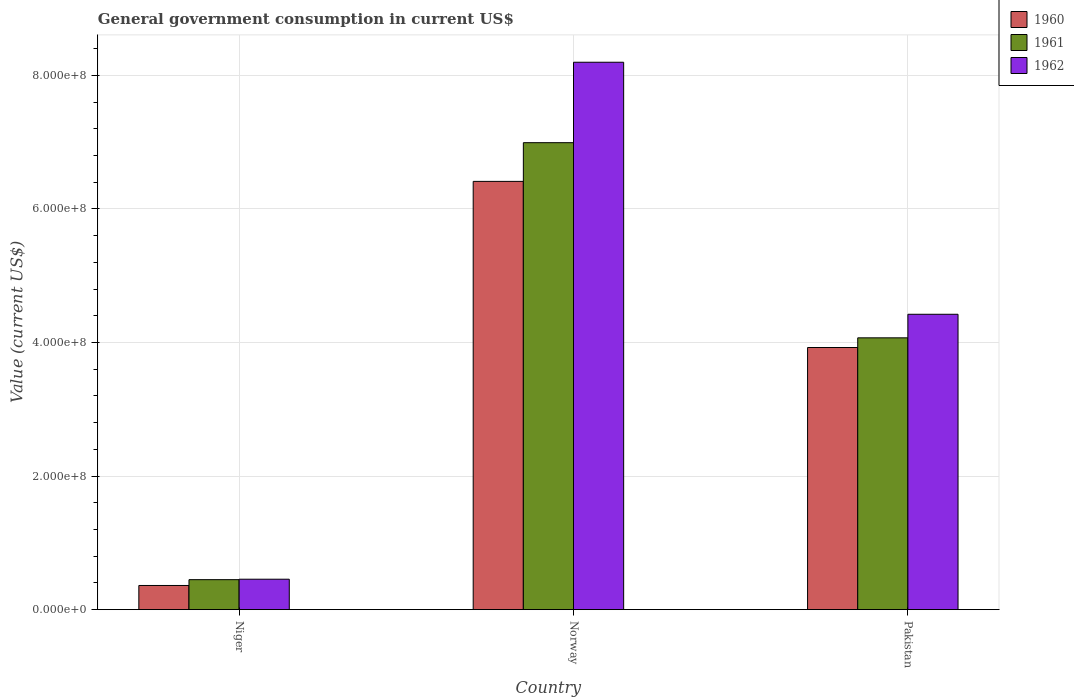How many different coloured bars are there?
Offer a terse response. 3. Are the number of bars per tick equal to the number of legend labels?
Provide a short and direct response. Yes. Are the number of bars on each tick of the X-axis equal?
Provide a short and direct response. Yes. How many bars are there on the 1st tick from the left?
Offer a very short reply. 3. In how many cases, is the number of bars for a given country not equal to the number of legend labels?
Make the answer very short. 0. What is the government conusmption in 1961 in Norway?
Offer a very short reply. 6.99e+08. Across all countries, what is the maximum government conusmption in 1961?
Offer a terse response. 6.99e+08. Across all countries, what is the minimum government conusmption in 1962?
Offer a very short reply. 4.55e+07. In which country was the government conusmption in 1962 minimum?
Make the answer very short. Niger. What is the total government conusmption in 1962 in the graph?
Provide a short and direct response. 1.31e+09. What is the difference between the government conusmption in 1960 in Niger and that in Norway?
Your answer should be compact. -6.05e+08. What is the difference between the government conusmption in 1960 in Norway and the government conusmption in 1961 in Pakistan?
Provide a succinct answer. 2.34e+08. What is the average government conusmption in 1960 per country?
Offer a terse response. 3.57e+08. What is the difference between the government conusmption of/in 1960 and government conusmption of/in 1961 in Norway?
Keep it short and to the point. -5.80e+07. What is the ratio of the government conusmption in 1962 in Norway to that in Pakistan?
Ensure brevity in your answer.  1.85. Is the government conusmption in 1960 in Norway less than that in Pakistan?
Your response must be concise. No. Is the difference between the government conusmption in 1960 in Niger and Norway greater than the difference between the government conusmption in 1961 in Niger and Norway?
Your response must be concise. Yes. What is the difference between the highest and the second highest government conusmption in 1962?
Your answer should be compact. 3.77e+08. What is the difference between the highest and the lowest government conusmption in 1960?
Provide a succinct answer. 6.05e+08. In how many countries, is the government conusmption in 1962 greater than the average government conusmption in 1962 taken over all countries?
Your answer should be compact. 2. What does the 1st bar from the left in Norway represents?
Provide a short and direct response. 1960. Is it the case that in every country, the sum of the government conusmption in 1961 and government conusmption in 1962 is greater than the government conusmption in 1960?
Make the answer very short. Yes. Are all the bars in the graph horizontal?
Ensure brevity in your answer.  No. Are the values on the major ticks of Y-axis written in scientific E-notation?
Offer a terse response. Yes. Does the graph contain grids?
Offer a terse response. Yes. How many legend labels are there?
Keep it short and to the point. 3. How are the legend labels stacked?
Your response must be concise. Vertical. What is the title of the graph?
Provide a short and direct response. General government consumption in current US$. What is the label or title of the X-axis?
Your response must be concise. Country. What is the label or title of the Y-axis?
Make the answer very short. Value (current US$). What is the Value (current US$) of 1960 in Niger?
Keep it short and to the point. 3.62e+07. What is the Value (current US$) of 1961 in Niger?
Provide a succinct answer. 4.49e+07. What is the Value (current US$) of 1962 in Niger?
Keep it short and to the point. 4.55e+07. What is the Value (current US$) in 1960 in Norway?
Provide a short and direct response. 6.41e+08. What is the Value (current US$) in 1961 in Norway?
Your response must be concise. 6.99e+08. What is the Value (current US$) of 1962 in Norway?
Provide a succinct answer. 8.20e+08. What is the Value (current US$) of 1960 in Pakistan?
Your answer should be very brief. 3.92e+08. What is the Value (current US$) in 1961 in Pakistan?
Give a very brief answer. 4.07e+08. What is the Value (current US$) in 1962 in Pakistan?
Provide a short and direct response. 4.42e+08. Across all countries, what is the maximum Value (current US$) in 1960?
Your answer should be compact. 6.41e+08. Across all countries, what is the maximum Value (current US$) in 1961?
Keep it short and to the point. 6.99e+08. Across all countries, what is the maximum Value (current US$) in 1962?
Offer a very short reply. 8.20e+08. Across all countries, what is the minimum Value (current US$) in 1960?
Your answer should be very brief. 3.62e+07. Across all countries, what is the minimum Value (current US$) in 1961?
Your response must be concise. 4.49e+07. Across all countries, what is the minimum Value (current US$) in 1962?
Offer a very short reply. 4.55e+07. What is the total Value (current US$) of 1960 in the graph?
Your answer should be compact. 1.07e+09. What is the total Value (current US$) of 1961 in the graph?
Offer a very short reply. 1.15e+09. What is the total Value (current US$) in 1962 in the graph?
Make the answer very short. 1.31e+09. What is the difference between the Value (current US$) of 1960 in Niger and that in Norway?
Ensure brevity in your answer.  -6.05e+08. What is the difference between the Value (current US$) of 1961 in Niger and that in Norway?
Your response must be concise. -6.54e+08. What is the difference between the Value (current US$) of 1962 in Niger and that in Norway?
Ensure brevity in your answer.  -7.74e+08. What is the difference between the Value (current US$) of 1960 in Niger and that in Pakistan?
Ensure brevity in your answer.  -3.56e+08. What is the difference between the Value (current US$) of 1961 in Niger and that in Pakistan?
Offer a terse response. -3.62e+08. What is the difference between the Value (current US$) of 1962 in Niger and that in Pakistan?
Keep it short and to the point. -3.97e+08. What is the difference between the Value (current US$) of 1960 in Norway and that in Pakistan?
Give a very brief answer. 2.49e+08. What is the difference between the Value (current US$) in 1961 in Norway and that in Pakistan?
Ensure brevity in your answer.  2.92e+08. What is the difference between the Value (current US$) of 1962 in Norway and that in Pakistan?
Offer a very short reply. 3.77e+08. What is the difference between the Value (current US$) of 1960 in Niger and the Value (current US$) of 1961 in Norway?
Give a very brief answer. -6.63e+08. What is the difference between the Value (current US$) in 1960 in Niger and the Value (current US$) in 1962 in Norway?
Offer a terse response. -7.83e+08. What is the difference between the Value (current US$) in 1961 in Niger and the Value (current US$) in 1962 in Norway?
Provide a succinct answer. -7.75e+08. What is the difference between the Value (current US$) in 1960 in Niger and the Value (current US$) in 1961 in Pakistan?
Provide a succinct answer. -3.71e+08. What is the difference between the Value (current US$) of 1960 in Niger and the Value (current US$) of 1962 in Pakistan?
Your answer should be compact. -4.06e+08. What is the difference between the Value (current US$) of 1961 in Niger and the Value (current US$) of 1962 in Pakistan?
Offer a very short reply. -3.97e+08. What is the difference between the Value (current US$) in 1960 in Norway and the Value (current US$) in 1961 in Pakistan?
Offer a terse response. 2.34e+08. What is the difference between the Value (current US$) of 1960 in Norway and the Value (current US$) of 1962 in Pakistan?
Your answer should be compact. 1.99e+08. What is the difference between the Value (current US$) in 1961 in Norway and the Value (current US$) in 1962 in Pakistan?
Offer a very short reply. 2.57e+08. What is the average Value (current US$) in 1960 per country?
Provide a short and direct response. 3.57e+08. What is the average Value (current US$) of 1961 per country?
Your answer should be compact. 3.84e+08. What is the average Value (current US$) in 1962 per country?
Offer a very short reply. 4.36e+08. What is the difference between the Value (current US$) of 1960 and Value (current US$) of 1961 in Niger?
Offer a very short reply. -8.72e+06. What is the difference between the Value (current US$) of 1960 and Value (current US$) of 1962 in Niger?
Your answer should be compact. -9.38e+06. What is the difference between the Value (current US$) of 1961 and Value (current US$) of 1962 in Niger?
Give a very brief answer. -6.69e+05. What is the difference between the Value (current US$) of 1960 and Value (current US$) of 1961 in Norway?
Offer a terse response. -5.80e+07. What is the difference between the Value (current US$) of 1960 and Value (current US$) of 1962 in Norway?
Make the answer very short. -1.78e+08. What is the difference between the Value (current US$) of 1961 and Value (current US$) of 1962 in Norway?
Your answer should be compact. -1.20e+08. What is the difference between the Value (current US$) in 1960 and Value (current US$) in 1961 in Pakistan?
Keep it short and to the point. -1.45e+07. What is the difference between the Value (current US$) of 1960 and Value (current US$) of 1962 in Pakistan?
Provide a succinct answer. -4.98e+07. What is the difference between the Value (current US$) of 1961 and Value (current US$) of 1962 in Pakistan?
Your answer should be compact. -3.53e+07. What is the ratio of the Value (current US$) in 1960 in Niger to that in Norway?
Make the answer very short. 0.06. What is the ratio of the Value (current US$) of 1961 in Niger to that in Norway?
Offer a very short reply. 0.06. What is the ratio of the Value (current US$) of 1962 in Niger to that in Norway?
Your answer should be very brief. 0.06. What is the ratio of the Value (current US$) of 1960 in Niger to that in Pakistan?
Offer a terse response. 0.09. What is the ratio of the Value (current US$) of 1961 in Niger to that in Pakistan?
Keep it short and to the point. 0.11. What is the ratio of the Value (current US$) of 1962 in Niger to that in Pakistan?
Give a very brief answer. 0.1. What is the ratio of the Value (current US$) of 1960 in Norway to that in Pakistan?
Give a very brief answer. 1.63. What is the ratio of the Value (current US$) of 1961 in Norway to that in Pakistan?
Your answer should be compact. 1.72. What is the ratio of the Value (current US$) of 1962 in Norway to that in Pakistan?
Give a very brief answer. 1.85. What is the difference between the highest and the second highest Value (current US$) in 1960?
Your answer should be very brief. 2.49e+08. What is the difference between the highest and the second highest Value (current US$) of 1961?
Your response must be concise. 2.92e+08. What is the difference between the highest and the second highest Value (current US$) of 1962?
Offer a terse response. 3.77e+08. What is the difference between the highest and the lowest Value (current US$) of 1960?
Make the answer very short. 6.05e+08. What is the difference between the highest and the lowest Value (current US$) in 1961?
Provide a short and direct response. 6.54e+08. What is the difference between the highest and the lowest Value (current US$) of 1962?
Offer a very short reply. 7.74e+08. 